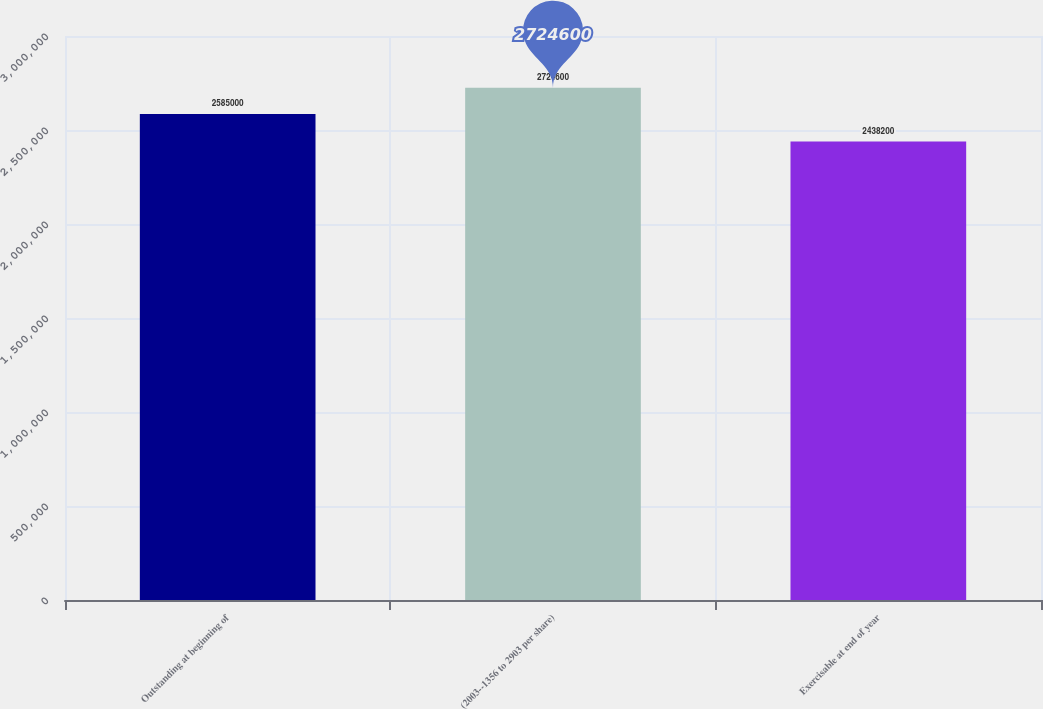Convert chart. <chart><loc_0><loc_0><loc_500><loc_500><bar_chart><fcel>Outstanding at beginning of<fcel>(2003--1356 to 2903 per share)<fcel>Exercisable at end of year<nl><fcel>2.585e+06<fcel>2.7246e+06<fcel>2.4382e+06<nl></chart> 